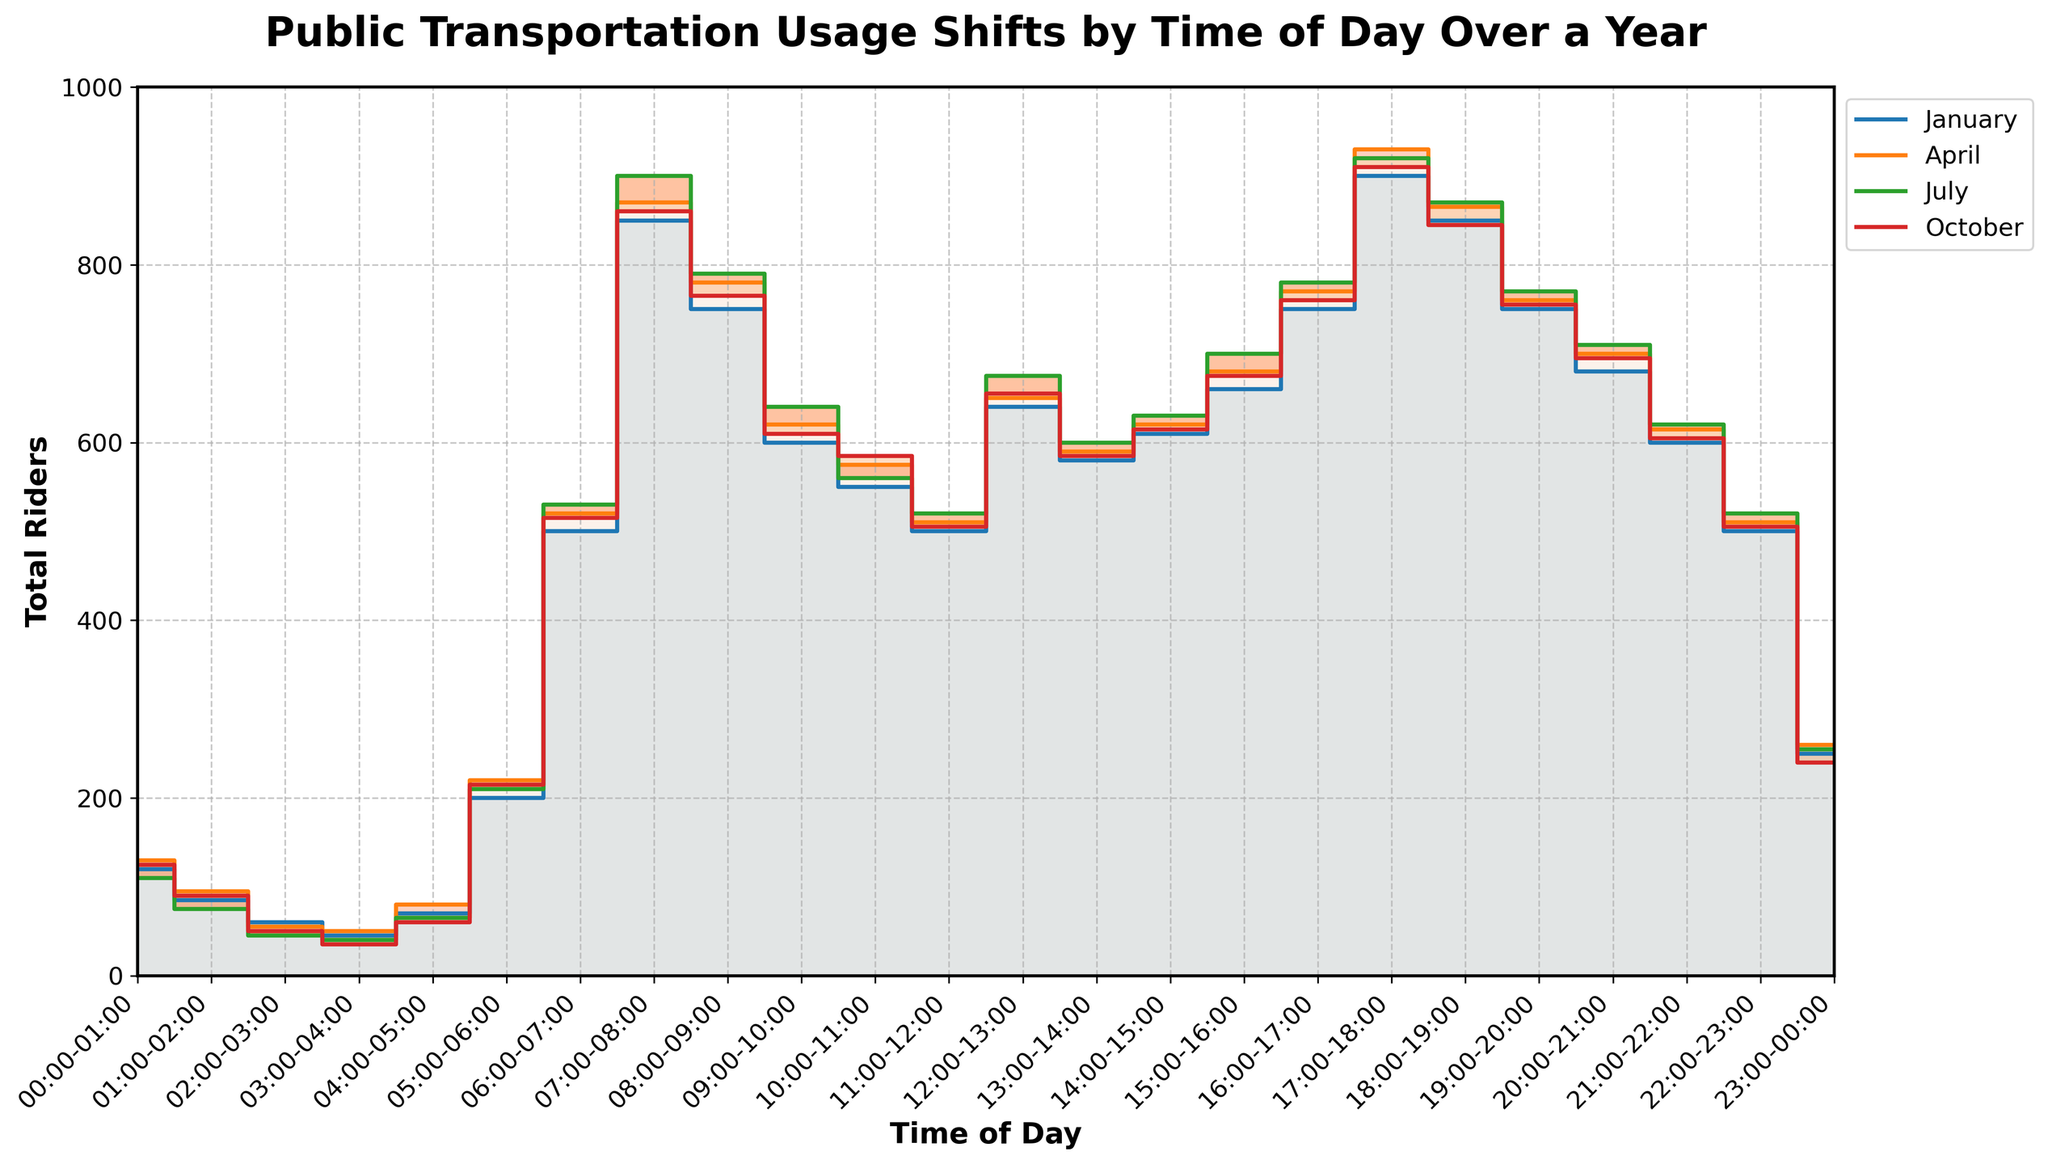What's the title of the plot? The title of the plot is typically displayed at the top of the chart in a larger and bold font. For this specific plot, the title is "Public Transportation Usage Shifts by Time of Day Over a Year."
Answer: Public Transportation Usage Shifts by Time of Day Over a Year How many time intervals are displayed on the x-axis? The plot's x-axis shows time intervals, and based on the data provided, there are 24 time intervals, each representing one hour of the day.
Answer: 24 Which month has the highest rider count for the time interval 17:00-18:00? For the time interval 17:00-18:00, the plot indicates that both July and October have the highest rider counts, each reaching 920 and 910 respectively. By visually inspecting the step lines in the chart, we can identify that the peaks for this time interval coincide with these two months.
Answer: July How does the number of riders change between 06:00-07:00 and 07:00-08:00 in January? In January, the number of riders increases from 500 during the 06:00-07:00 interval to 850 during the 07:00-08:00 interval. By subtracting 500 from 850, we find there is an increase of 350 riders.
Answer: Increases by 350 Which month has the lowest rider count at 02:00-03:00? To determine the lowest rider count for the 02:00-03:00 interval, we look at the data lines corresponding to each month. The lowest count for this interval is observed in July with only 45 riders.
Answer: July During which time of day does the biggest difference in rider counts occur between January and July? To find the largest difference between January and July, we need to check the intervals where the lines for these months show the maximum gap. By comparing each time interval, we find that the biggest difference occurs at 07:00-08:00 with 900 riders in July and 850 riders in January, resulting in a difference of 50.
Answer: 07:00-08:00 What is the average number of total riders for the time interval 12:00-13:00 across all four months? First, sum the number of riders for the time interval 12:00-13:00 across all four months: 640 (January) + 650 (April) + 675 (July) + 655 (October). This gives a total of 2620 riders. To find the average, we then divide this total by 4, yielding an average of 655 riders.
Answer: 655 During which time interval do all four months have the lowest rider counts? By examining the plot for the lowest rider counts across all four months, we see that the interval 03:00-04:00 consistently has low values: 45 (January), 50 (April), 40 (July), and 35 (October). Thus, this interval has the lowest rider counts in each month.
Answer: 03:00-04:00 Which time interval shows a consistent increase in total riders from January to October? By assessing the consistent increase in rider numbers across the intervals from January to October, we see that the time interval between 15:00-16:00 shows a steady increment: 660 (January), 680 (April), 700 (July), and 675 (October), indicating a consistent increase.
Answer: 15:00-16:00 